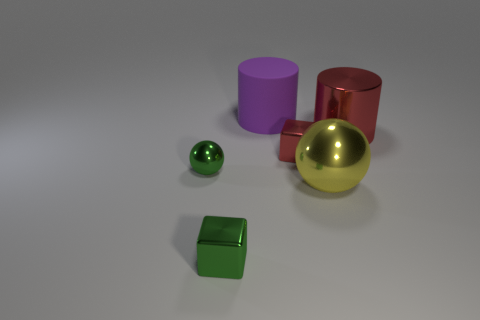Add 3 small brown things. How many objects exist? 9 Subtract all cubes. How many objects are left? 4 Add 3 large red metallic objects. How many large red metallic objects are left? 4 Add 2 tiny spheres. How many tiny spheres exist? 3 Subtract 0 yellow cubes. How many objects are left? 6 Subtract all large yellow metallic objects. Subtract all matte objects. How many objects are left? 4 